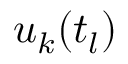Convert formula to latex. <formula><loc_0><loc_0><loc_500><loc_500>u _ { k } ( t _ { l } )</formula> 